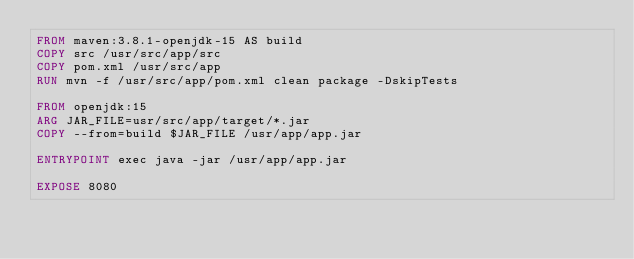<code> <loc_0><loc_0><loc_500><loc_500><_Dockerfile_>FROM maven:3.8.1-openjdk-15 AS build
COPY src /usr/src/app/src
COPY pom.xml /usr/src/app
RUN mvn -f /usr/src/app/pom.xml clean package -DskipTests

FROM openjdk:15
ARG JAR_FILE=usr/src/app/target/*.jar
COPY --from=build $JAR_FILE /usr/app/app.jar

ENTRYPOINT exec java -jar /usr/app/app.jar

EXPOSE 8080</code> 